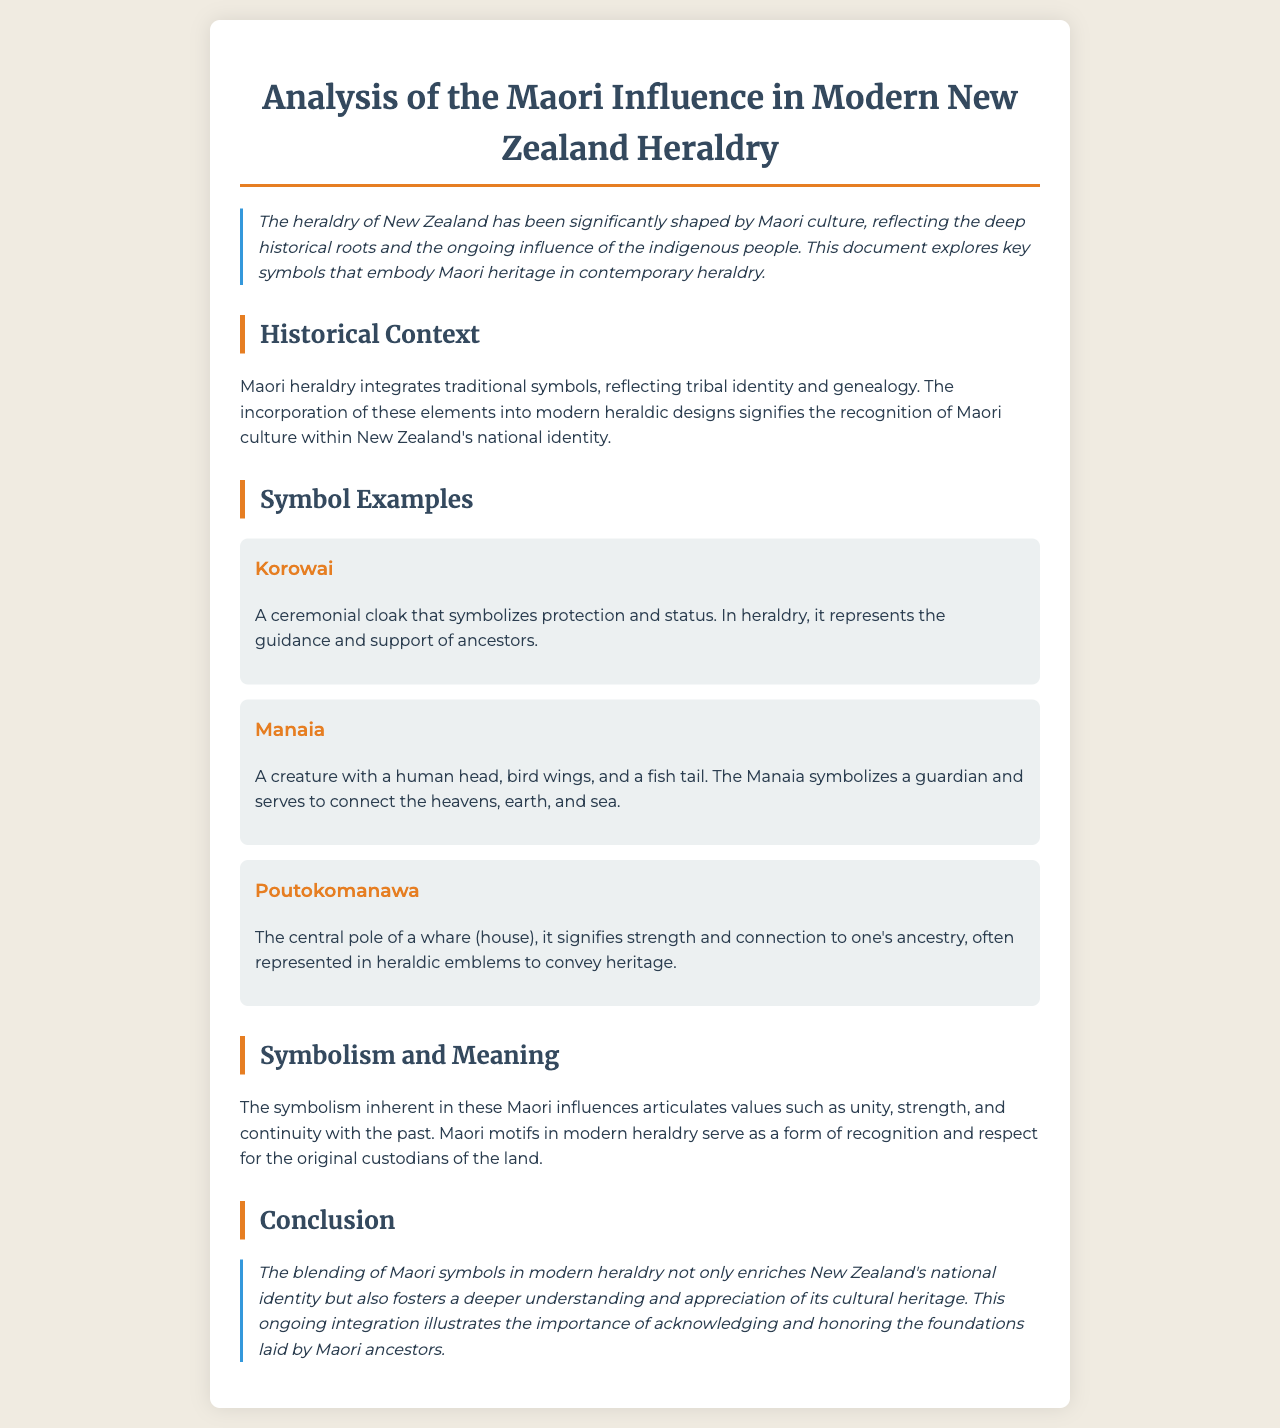what is the title of the document? The title is displayed prominently at the top of the document.
Answer: Analysis of the Maori Influence in Modern New Zealand Heraldry what does the Korowai symbolize? The document describes the Korowai and its symbolic meanings.
Answer: protection and status what creature represents a guardian in Maori heraldry? The document specifies a creature that symbolizes a guardian.
Answer: Manaia what is the significance of the Poutokomanawa? The document explains the meaning of the Poutokomanawa in heraldry.
Answer: strength and connection to one's ancestry what values do Maori influences in heraldry articulate? The document states the values represented by Maori symbols in modern heraldry.
Answer: unity, strength, and continuity with the past how does the document classify its sections? The document comprises various structured sections to delve into the topic.
Answer: Historical Context, Symbol Examples, Symbolism and Meaning, Conclusion why is Maori culture included in modern heraldry? The document addresses the rationale behind incorporating Maori elements into heraldry.
Answer: recognition of Maori culture within New Zealand's national identity what does the conclusion emphasize about Maori symbols? The conclusion summarizes the impact of Maori symbols in the context of national identity.
Answer: acknowledgment and honoring the foundations laid by Maori ancestors 